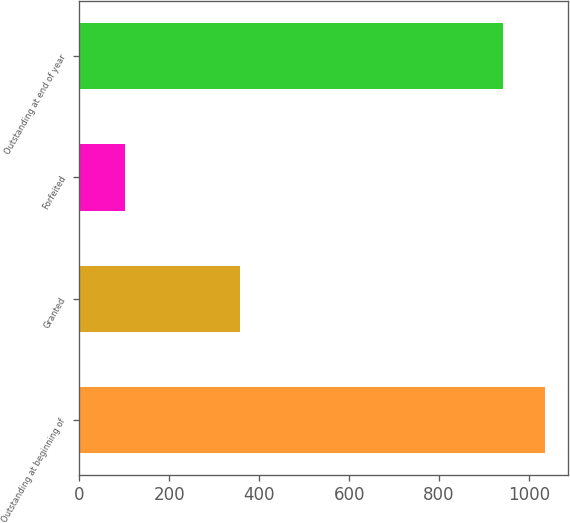Convert chart to OTSL. <chart><loc_0><loc_0><loc_500><loc_500><bar_chart><fcel>Outstanding at beginning of<fcel>Granted<fcel>Forfeited<fcel>Outstanding at end of year<nl><fcel>1034.8<fcel>358<fcel>101<fcel>943<nl></chart> 